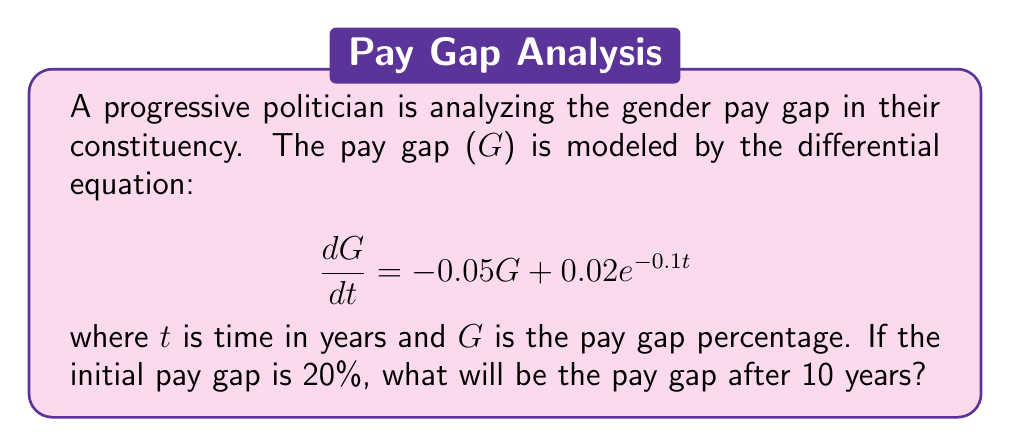Help me with this question. To solve this problem, we need to use the method for solving first-order linear differential equations.

1) The general form of a first-order linear DE is:
   $$\frac{dy}{dx} + P(x)y = Q(x)$$

2) In our case:
   $$\frac{dG}{dt} + 0.05G = 0.02e^{-0.1t}$$

3) The integrating factor is:
   $$\mu(t) = e^{\int P(t) dt} = e^{\int 0.05 dt} = e^{0.05t}$$

4) Multiply both sides of the equation by the integrating factor:
   $$e^{0.05t}\frac{dG}{dt} + 0.05e^{0.05t}G = 0.02e^{-0.1t}e^{0.05t}$$

5) The left side is now the derivative of $e^{0.05t}G$:
   $$\frac{d}{dt}(e^{0.05t}G) = 0.02e^{-0.05t}$$

6) Integrate both sides:
   $$e^{0.05t}G = \int 0.02e^{-0.05t}dt = -0.4e^{-0.05t} + C$$

7) Solve for G:
   $$G = -0.4e^{-0.1t} + Ce^{-0.05t}$$

8) Use the initial condition G(0) = 20% to find C:
   $$20 = -0.4 + C$$
   $$C = 20.4$$

9) The particular solution is:
   $$G = -0.4e^{-0.1t} + 20.4e^{-0.05t}$$

10) Evaluate G at t = 10:
    $$G(10) = -0.4e^{-0.1(10)} + 20.4e^{-0.05(10)}$$
    $$= -0.4(0.3679) + 20.4(0.6065)$$
    $$= -0.1472 + 12.3726$$
    $$= 12.2254$$

Therefore, after 10 years, the pay gap will be approximately 12.23%.
Answer: 12.23% 